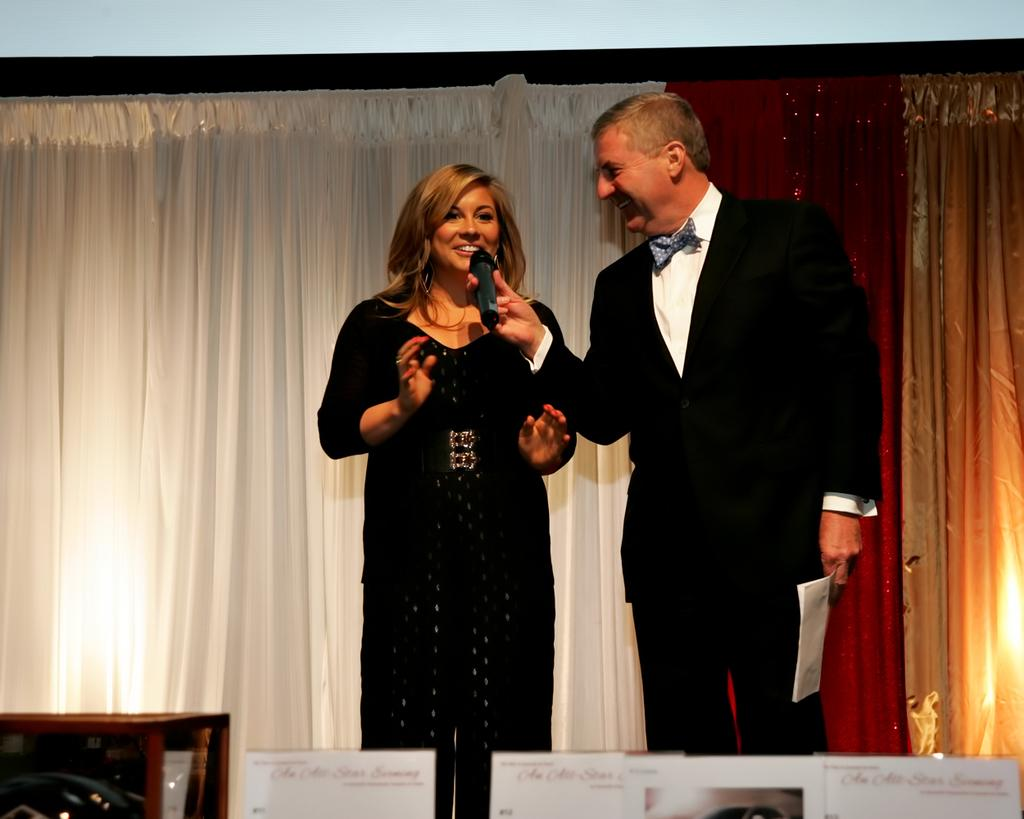How many people are in the image? There are two persons standing and smiling in the image. What are the people holding in the image? One person is holding a microphone, and the other person is holding a paper. What can be seen in the background of the image? There are curtains and boards in the background of the image. What type of eggnog is being served at the event in the image? There is no mention of eggnog or any event in the image; it simply shows two people holding a microphone and a paper. 